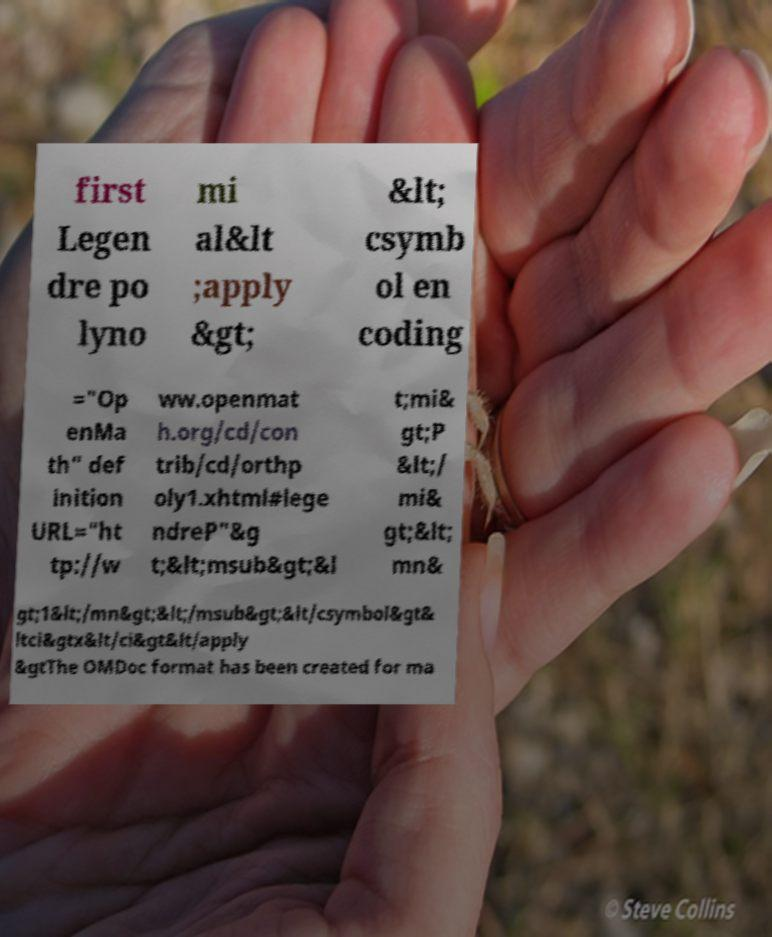Can you read and provide the text displayed in the image?This photo seems to have some interesting text. Can you extract and type it out for me? first Legen dre po lyno mi al&lt ;apply &gt; &lt; csymb ol en coding ="Op enMa th" def inition URL="ht tp://w ww.openmat h.org/cd/con trib/cd/orthp oly1.xhtml#lege ndreP"&g t;&lt;msub&gt;&l t;mi& gt;P &lt;/ mi& gt;&lt; mn& gt;1&lt;/mn&gt;&lt;/msub&gt;&lt/csymbol&gt& ltci&gtx&lt/ci&gt&lt/apply &gtThe OMDoc format has been created for ma 